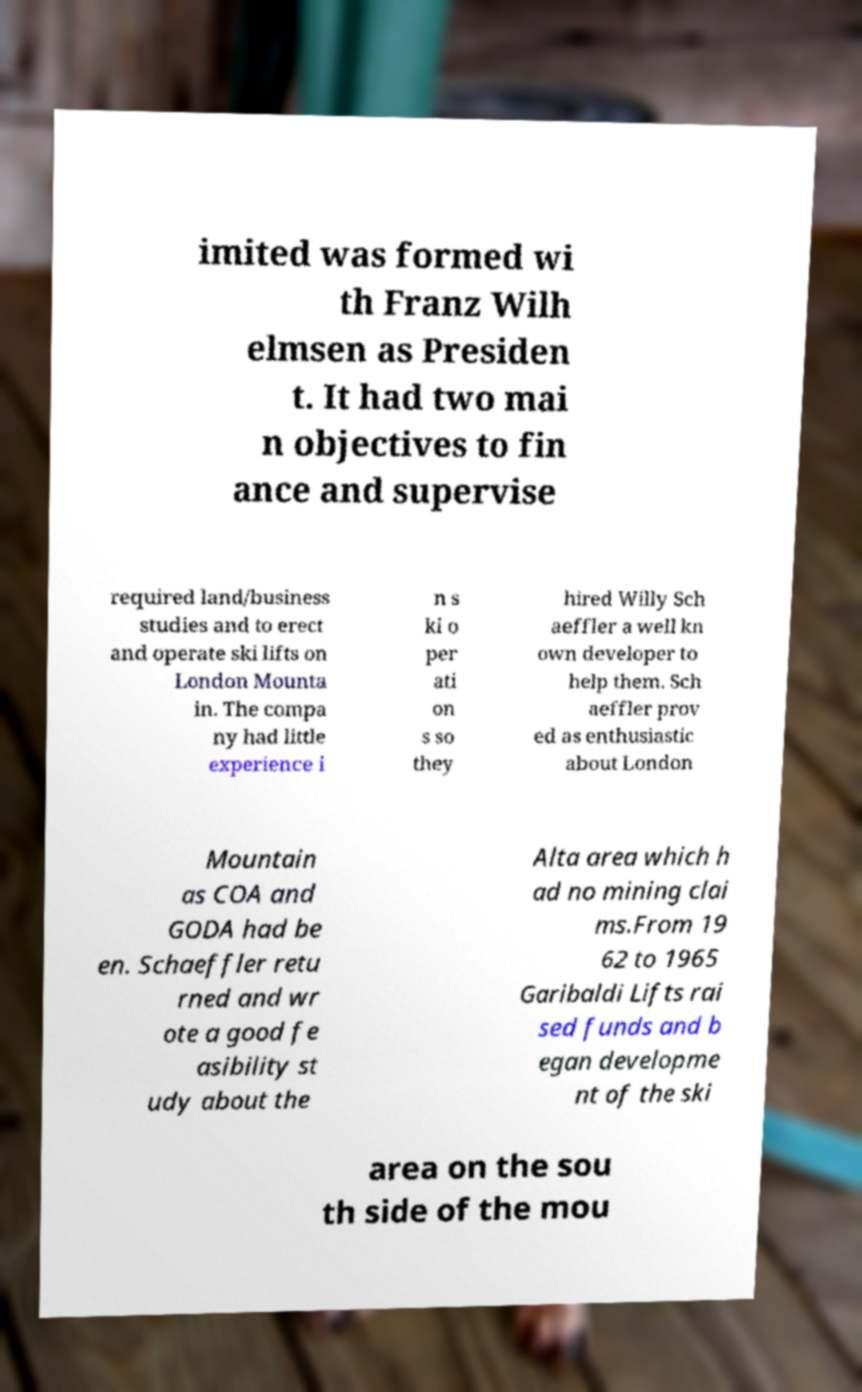There's text embedded in this image that I need extracted. Can you transcribe it verbatim? imited was formed wi th Franz Wilh elmsen as Presiden t. It had two mai n objectives to fin ance and supervise required land/business studies and to erect and operate ski lifts on London Mounta in. The compa ny had little experience i n s ki o per ati on s so they hired Willy Sch aeffler a well kn own developer to help them. Sch aeffler prov ed as enthusiastic about London Mountain as COA and GODA had be en. Schaeffler retu rned and wr ote a good fe asibility st udy about the Alta area which h ad no mining clai ms.From 19 62 to 1965 Garibaldi Lifts rai sed funds and b egan developme nt of the ski area on the sou th side of the mou 